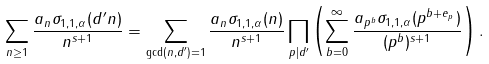Convert formula to latex. <formula><loc_0><loc_0><loc_500><loc_500>\sum _ { n \geq 1 } \frac { a _ { n } \sigma _ { 1 , 1 , \alpha } ( d ^ { \prime } n ) } { n ^ { s + 1 } } = \sum _ { \gcd ( n , d ^ { \prime } ) = 1 } \frac { a _ { n } \sigma _ { 1 , 1 , \alpha } ( n ) } { n ^ { s + 1 } } \prod _ { p | d ^ { \prime } } \left ( \sum _ { b = 0 } ^ { \infty } \frac { a _ { p ^ { b } } \sigma _ { 1 , 1 , \alpha } ( p ^ { b + e _ { p } } ) } { ( p ^ { b } ) ^ { s + 1 } } \right ) .</formula> 